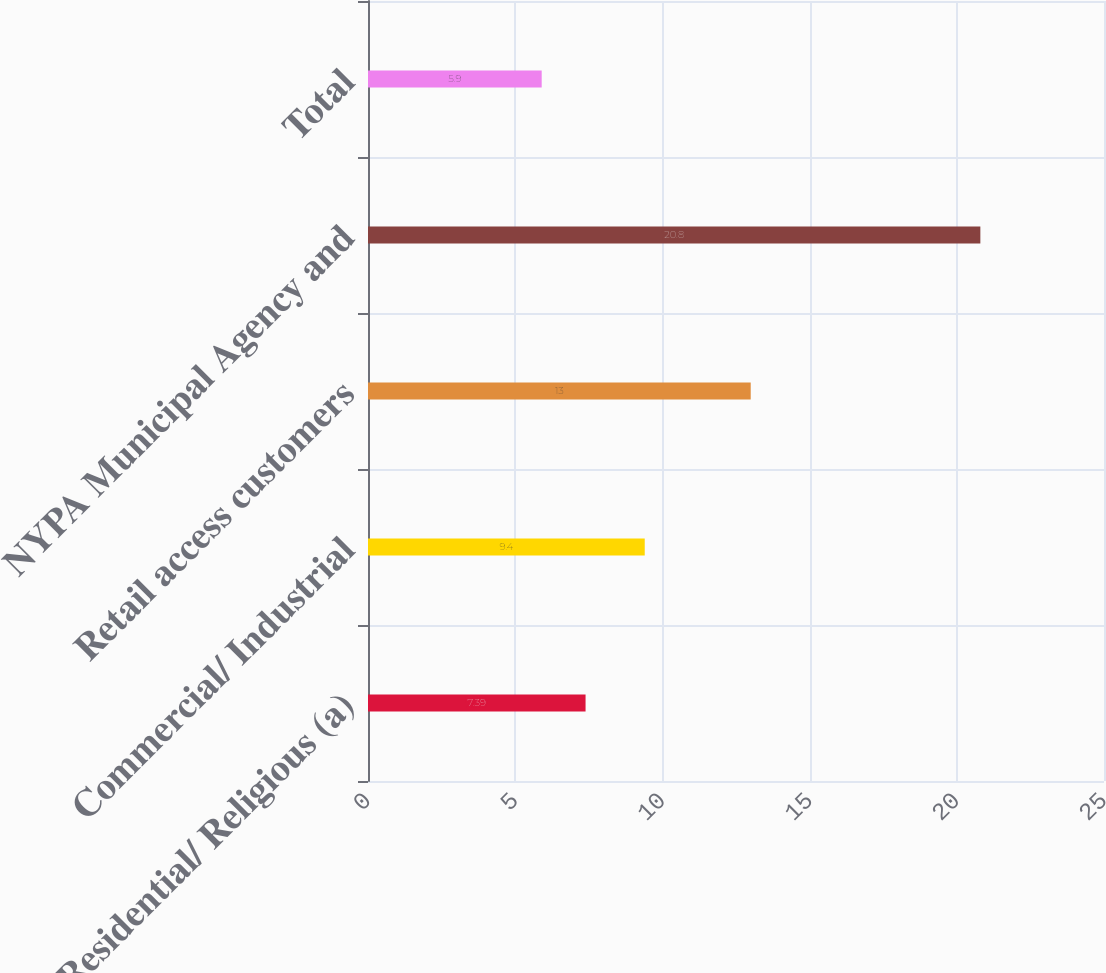<chart> <loc_0><loc_0><loc_500><loc_500><bar_chart><fcel>Residential/ Religious (a)<fcel>Commercial/ Industrial<fcel>Retail access customers<fcel>NYPA Municipal Agency and<fcel>Total<nl><fcel>7.39<fcel>9.4<fcel>13<fcel>20.8<fcel>5.9<nl></chart> 